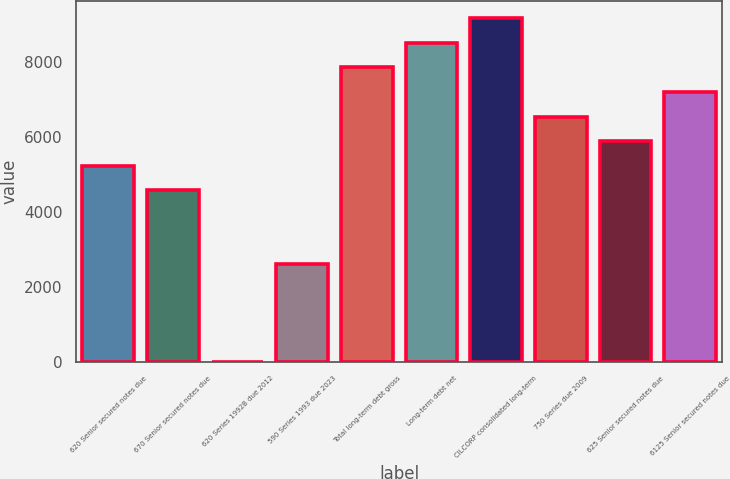Convert chart to OTSL. <chart><loc_0><loc_0><loc_500><loc_500><bar_chart><fcel>620 Senior secured notes due<fcel>670 Senior secured notes due<fcel>620 Series 1992B due 2012<fcel>590 Series 1993 due 2023<fcel>Total long-term debt gross<fcel>Long-term debt net<fcel>CILCORP consolidated long-term<fcel>750 Series due 2009<fcel>625 Senior secured notes due<fcel>6125 Senior secured notes due<nl><fcel>5243.4<fcel>4588.1<fcel>1<fcel>2622.2<fcel>7864.6<fcel>8519.9<fcel>9175.2<fcel>6554<fcel>5898.7<fcel>7209.3<nl></chart> 